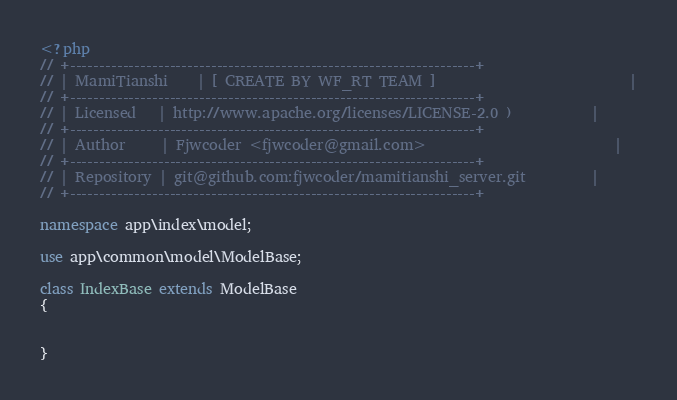<code> <loc_0><loc_0><loc_500><loc_500><_PHP_><?php
// +---------------------------------------------------------------------+
// | MamiTianshi    | [ CREATE BY WF_RT TEAM ]                           |
// +---------------------------------------------------------------------+
// | Licensed   | http://www.apache.org/licenses/LICENSE-2.0 )           |
// +---------------------------------------------------------------------+
// | Author     | Fjwcoder <fjwcoder@gmail.com>                          |
// +---------------------------------------------------------------------+
// | Repository | git@github.com:fjwcoder/mamitianshi_server.git         |
// +---------------------------------------------------------------------+

namespace app\index\model;

use app\common\model\ModelBase;

class IndexBase extends ModelBase
{
    
    
}
</code> 